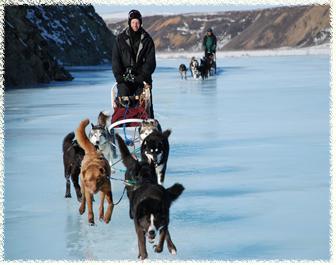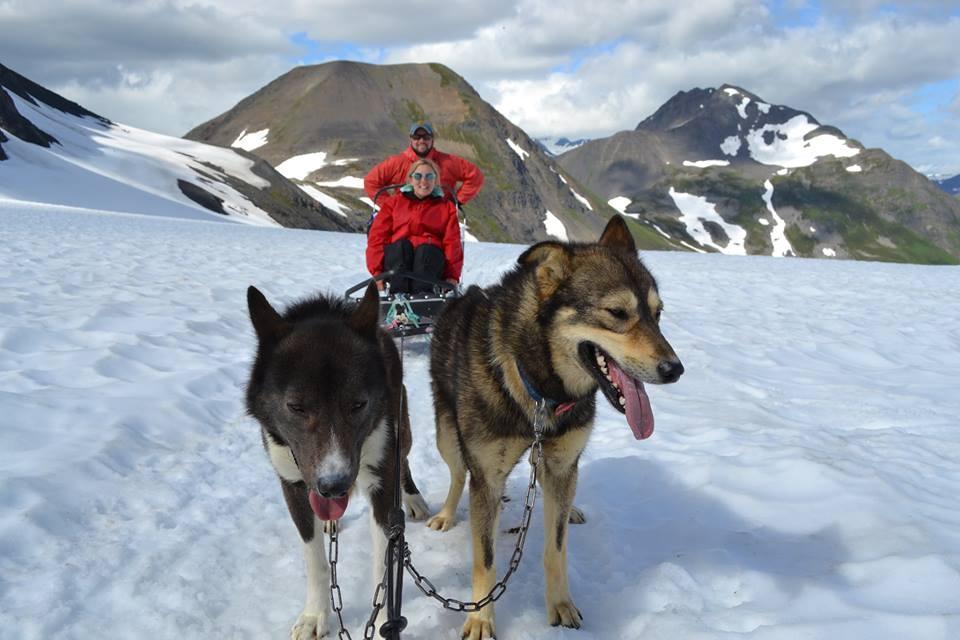The first image is the image on the left, the second image is the image on the right. Assess this claim about the two images: "There is a person in a red coat in the image on the right.". Correct or not? Answer yes or no. Yes. 